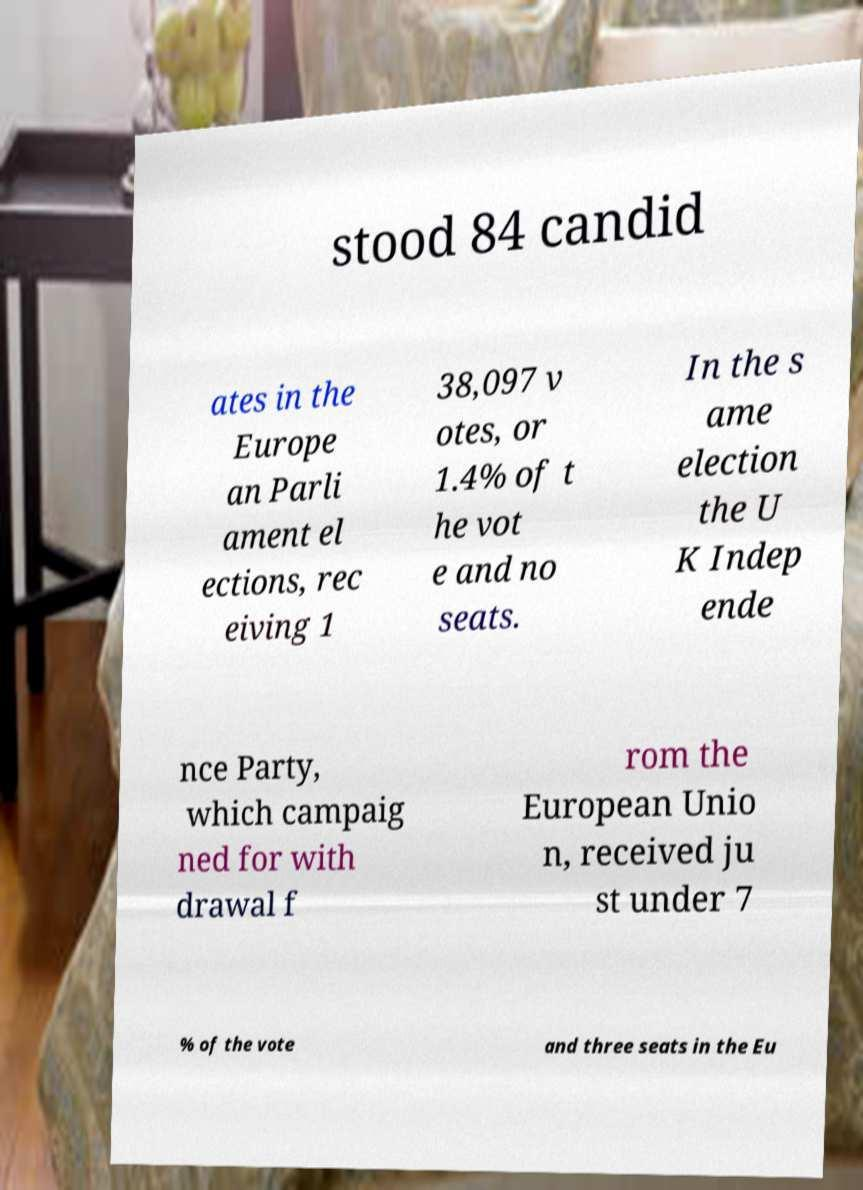Can you accurately transcribe the text from the provided image for me? stood 84 candid ates in the Europe an Parli ament el ections, rec eiving 1 38,097 v otes, or 1.4% of t he vot e and no seats. In the s ame election the U K Indep ende nce Party, which campaig ned for with drawal f rom the European Unio n, received ju st under 7 % of the vote and three seats in the Eu 